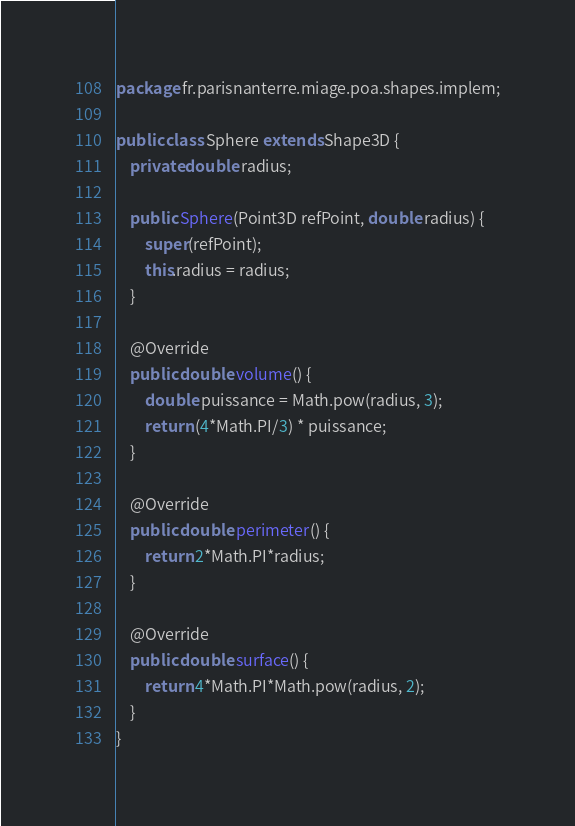<code> <loc_0><loc_0><loc_500><loc_500><_Java_>package fr.parisnanterre.miage.poa.shapes.implem;

public class Sphere extends Shape3D {
    private double radius;

    public Sphere(Point3D refPoint, double radius) {
        super(refPoint);
        this.radius = radius;
    }

    @Override
    public double volume() {
        double puissance = Math.pow(radius, 3);
        return (4*Math.PI/3) * puissance;
    }

    @Override
    public double perimeter() {
        return 2*Math.PI*radius;
    }

    @Override
    public double surface() {
        return 4*Math.PI*Math.pow(radius, 2);
    }
}
</code> 